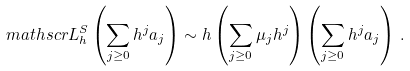Convert formula to latex. <formula><loc_0><loc_0><loc_500><loc_500>\ m a t h s c r { L } ^ { S } _ { h } \left ( \sum _ { j \geq 0 } h ^ { j } a _ { j } \right ) \sim h \left ( \sum _ { j \geq 0 } \mu _ { j } h ^ { j } \right ) \left ( \sum _ { j \geq 0 } h ^ { j } a _ { j } \right ) \, .</formula> 